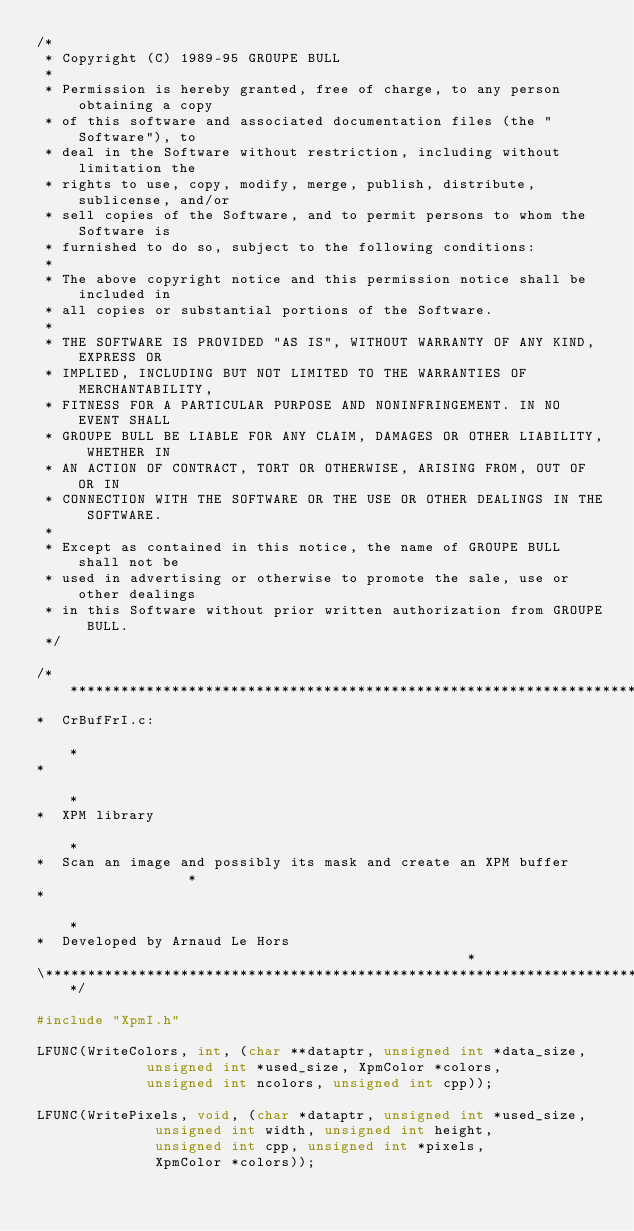<code> <loc_0><loc_0><loc_500><loc_500><_C_>/*
 * Copyright (C) 1989-95 GROUPE BULL
 *
 * Permission is hereby granted, free of charge, to any person obtaining a copy
 * of this software and associated documentation files (the "Software"), to
 * deal in the Software without restriction, including without limitation the
 * rights to use, copy, modify, merge, publish, distribute, sublicense, and/or
 * sell copies of the Software, and to permit persons to whom the Software is
 * furnished to do so, subject to the following conditions:
 *
 * The above copyright notice and this permission notice shall be included in
 * all copies or substantial portions of the Software.
 *
 * THE SOFTWARE IS PROVIDED "AS IS", WITHOUT WARRANTY OF ANY KIND, EXPRESS OR
 * IMPLIED, INCLUDING BUT NOT LIMITED TO THE WARRANTIES OF MERCHANTABILITY,
 * FITNESS FOR A PARTICULAR PURPOSE AND NONINFRINGEMENT. IN NO EVENT SHALL
 * GROUPE BULL BE LIABLE FOR ANY CLAIM, DAMAGES OR OTHER LIABILITY, WHETHER IN
 * AN ACTION OF CONTRACT, TORT OR OTHERWISE, ARISING FROM, OUT OF OR IN
 * CONNECTION WITH THE SOFTWARE OR THE USE OR OTHER DEALINGS IN THE SOFTWARE.
 *
 * Except as contained in this notice, the name of GROUPE BULL shall not be
 * used in advertising or otherwise to promote the sale, use or other dealings
 * in this Software without prior written authorization from GROUPE BULL.
 */

/*****************************************************************************\
*  CrBufFrI.c:                                                                *
*                                                                             *
*  XPM library                                                                *
*  Scan an image and possibly its mask and create an XPM buffer               *
*                                                                             *
*  Developed by Arnaud Le Hors                                                *
\*****************************************************************************/

#include "XpmI.h"

LFUNC(WriteColors, int, (char **dataptr, unsigned int *data_size,
			 unsigned int *used_size, XpmColor *colors,
			 unsigned int ncolors, unsigned int cpp));

LFUNC(WritePixels, void, (char *dataptr, unsigned int *used_size,
			  unsigned int width, unsigned int height,
			  unsigned int cpp, unsigned int *pixels,
			  XpmColor *colors));
</code> 